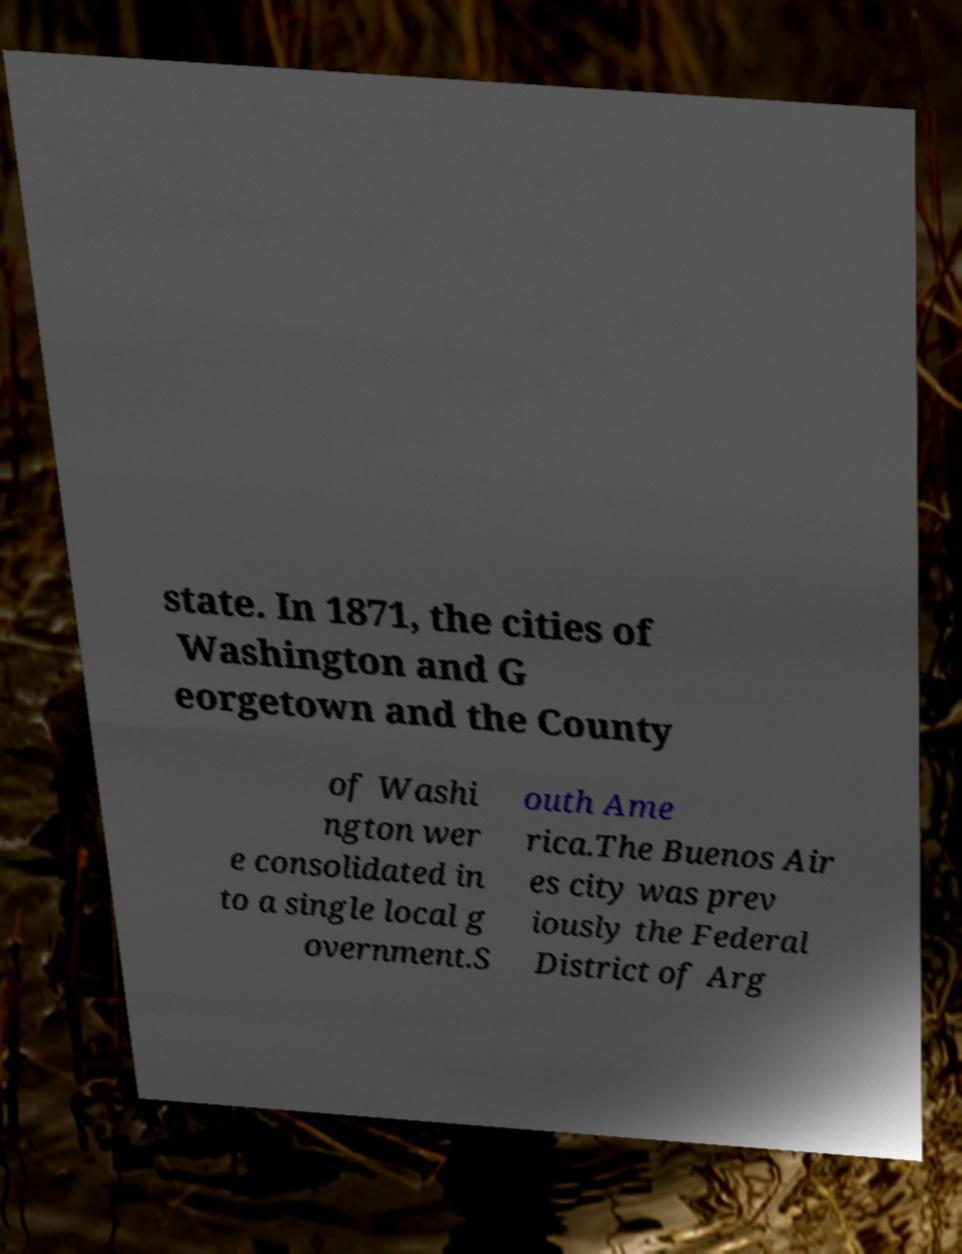Please identify and transcribe the text found in this image. state. In 1871, the cities of Washington and G eorgetown and the County of Washi ngton wer e consolidated in to a single local g overnment.S outh Ame rica.The Buenos Air es city was prev iously the Federal District of Arg 